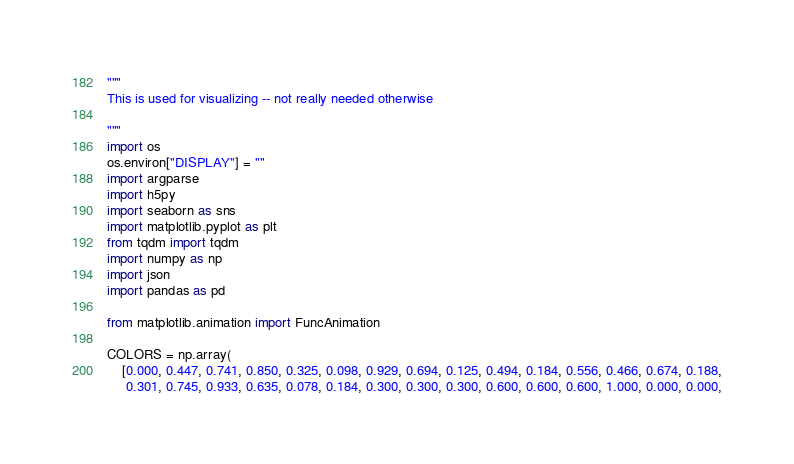Convert code to text. <code><loc_0><loc_0><loc_500><loc_500><_Python_>"""
This is used for visualizing -- not really needed otherwise

"""
import os
os.environ["DISPLAY"] = ""
import argparse
import h5py
import seaborn as sns
import matplotlib.pyplot as plt
from tqdm import tqdm
import numpy as np
import json
import pandas as pd

from matplotlib.animation import FuncAnimation

COLORS = np.array(
    [0.000, 0.447, 0.741, 0.850, 0.325, 0.098, 0.929, 0.694, 0.125, 0.494, 0.184, 0.556, 0.466, 0.674, 0.188,
     0.301, 0.745, 0.933, 0.635, 0.078, 0.184, 0.300, 0.300, 0.300, 0.600, 0.600, 0.600, 1.000, 0.000, 0.000,</code> 